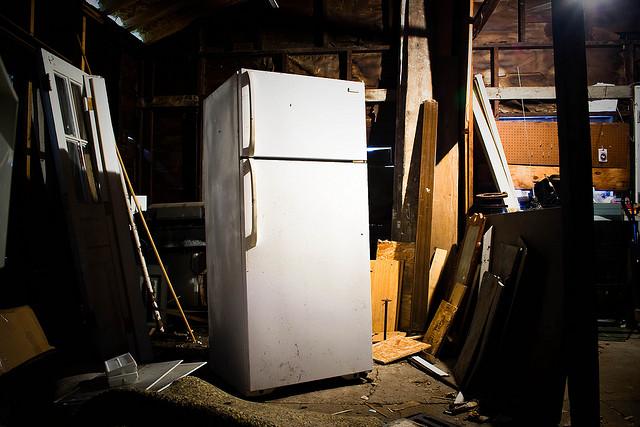Is this an old fridge?
Give a very brief answer. Yes. What color is the refrigerator?
Concise answer only. White. Is this a basement?
Short answer required. Yes. 